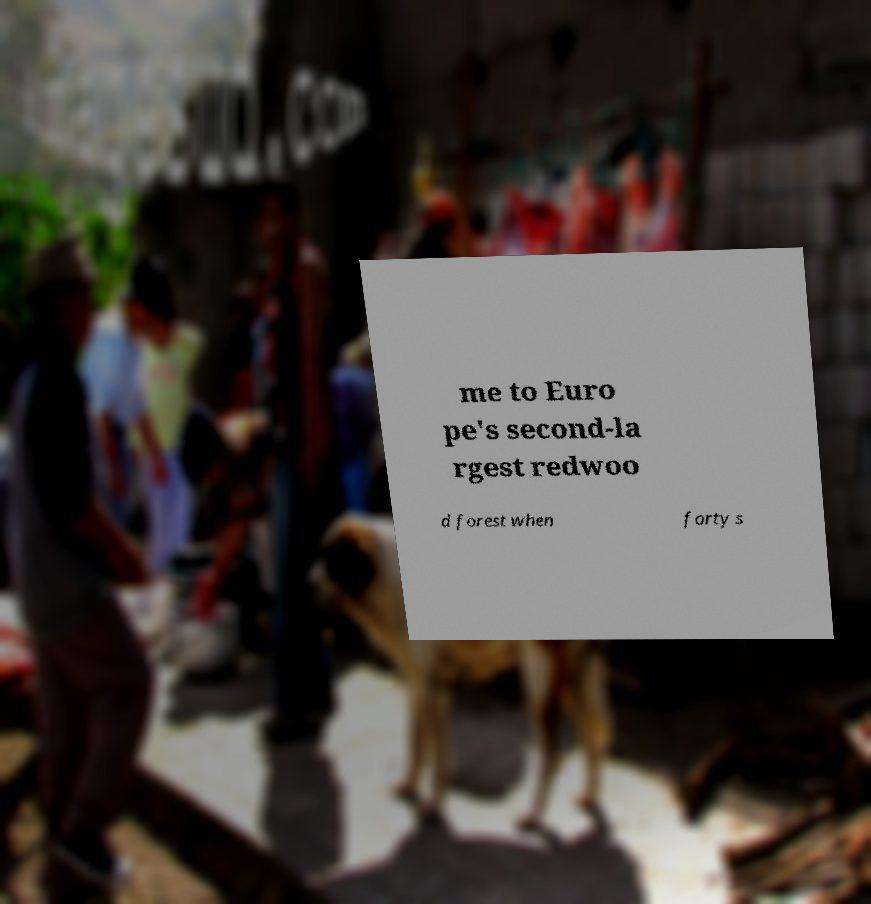Can you read and provide the text displayed in the image?This photo seems to have some interesting text. Can you extract and type it out for me? me to Euro pe's second-la rgest redwoo d forest when forty s 